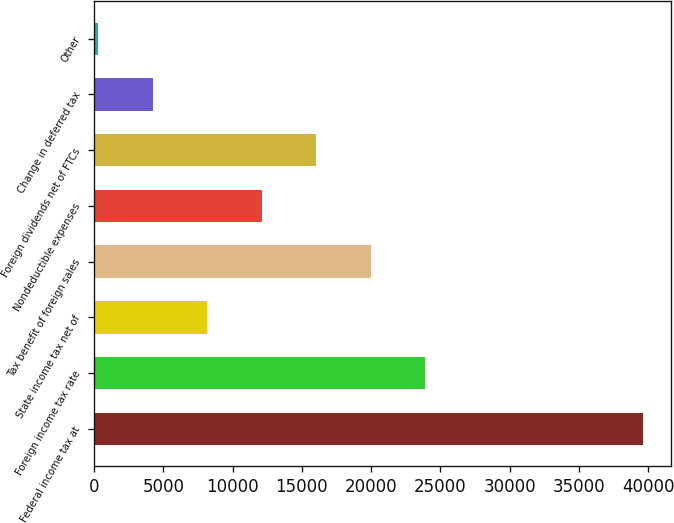<chart> <loc_0><loc_0><loc_500><loc_500><bar_chart><fcel>Federal income tax at<fcel>Foreign income tax rate<fcel>State income tax net of<fcel>Tax benefit of foreign sales<fcel>Nondeductible expenses<fcel>Foreign dividends net of FTCs<fcel>Change in deferred tax<fcel>Other<nl><fcel>39668<fcel>23917.6<fcel>8167.2<fcel>19980<fcel>12104.8<fcel>16042.4<fcel>4229.6<fcel>292<nl></chart> 